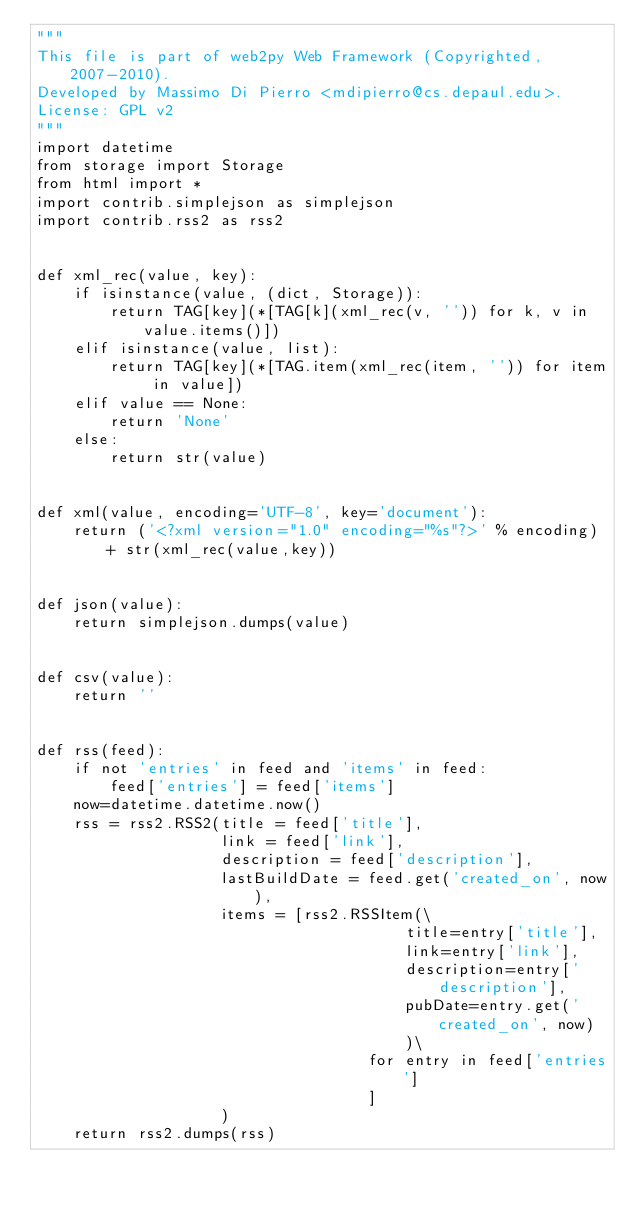Convert code to text. <code><loc_0><loc_0><loc_500><loc_500><_Python_>"""
This file is part of web2py Web Framework (Copyrighted, 2007-2010).
Developed by Massimo Di Pierro <mdipierro@cs.depaul.edu>.
License: GPL v2
"""
import datetime
from storage import Storage
from html import *
import contrib.simplejson as simplejson
import contrib.rss2 as rss2


def xml_rec(value, key):
    if isinstance(value, (dict, Storage)):
        return TAG[key](*[TAG[k](xml_rec(v, '')) for k, v in value.items()])
    elif isinstance(value, list):
        return TAG[key](*[TAG.item(xml_rec(item, '')) for item in value])
    elif value == None:
        return 'None'
    else:
        return str(value)


def xml(value, encoding='UTF-8', key='document'):
    return ('<?xml version="1.0" encoding="%s"?>' % encoding) + str(xml_rec(value,key))


def json(value):
    return simplejson.dumps(value)


def csv(value):
    return ''


def rss(feed):
    if not 'entries' in feed and 'items' in feed:
        feed['entries'] = feed['items']
    now=datetime.datetime.now()
    rss = rss2.RSS2(title = feed['title'],
                    link = feed['link'],
                    description = feed['description'],
                    lastBuildDate = feed.get('created_on', now),
                    items = [rss2.RSSItem(\
                                        title=entry['title'],
                                        link=entry['link'],
                                        description=entry['description'],
                                        pubDate=entry.get('created_on', now)
                                        )\
                                    for entry in feed['entries']
                                    ]
                    )
    return rss2.dumps(rss)
</code> 